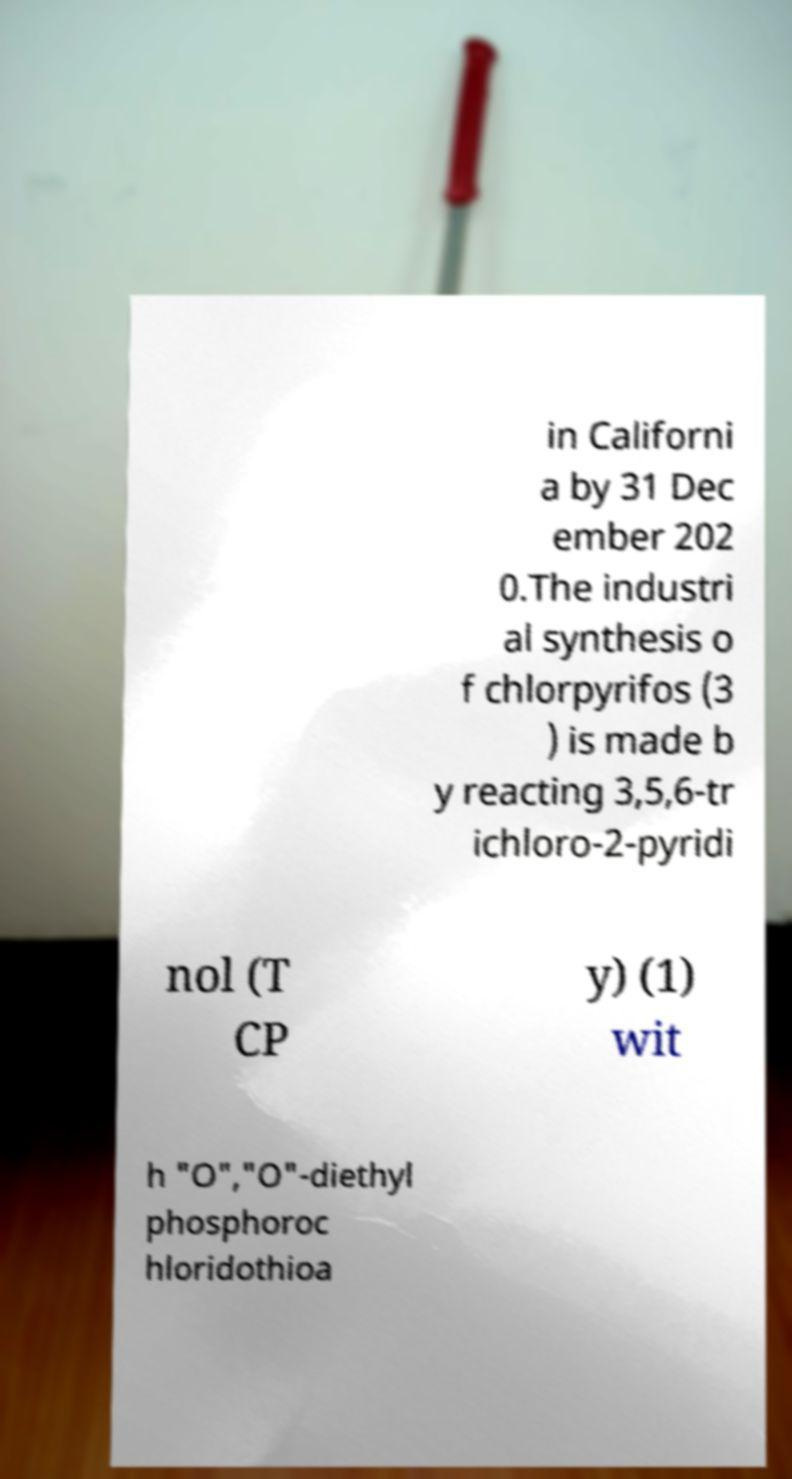What messages or text are displayed in this image? I need them in a readable, typed format. in Californi a by 31 Dec ember 202 0.The industri al synthesis o f chlorpyrifos (3 ) is made b y reacting 3,5,6-tr ichloro-2-pyridi nol (T CP y) (1) wit h "O","O"-diethyl phosphoroc hloridothioa 